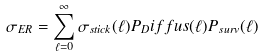<formula> <loc_0><loc_0><loc_500><loc_500>\sigma _ { E R } = \sum _ { \ell = 0 } ^ { \infty } \sigma _ { s t i c k } ( \ell ) P _ { D } i f f u s ( \ell ) P _ { s u r v } ( \ell )</formula> 